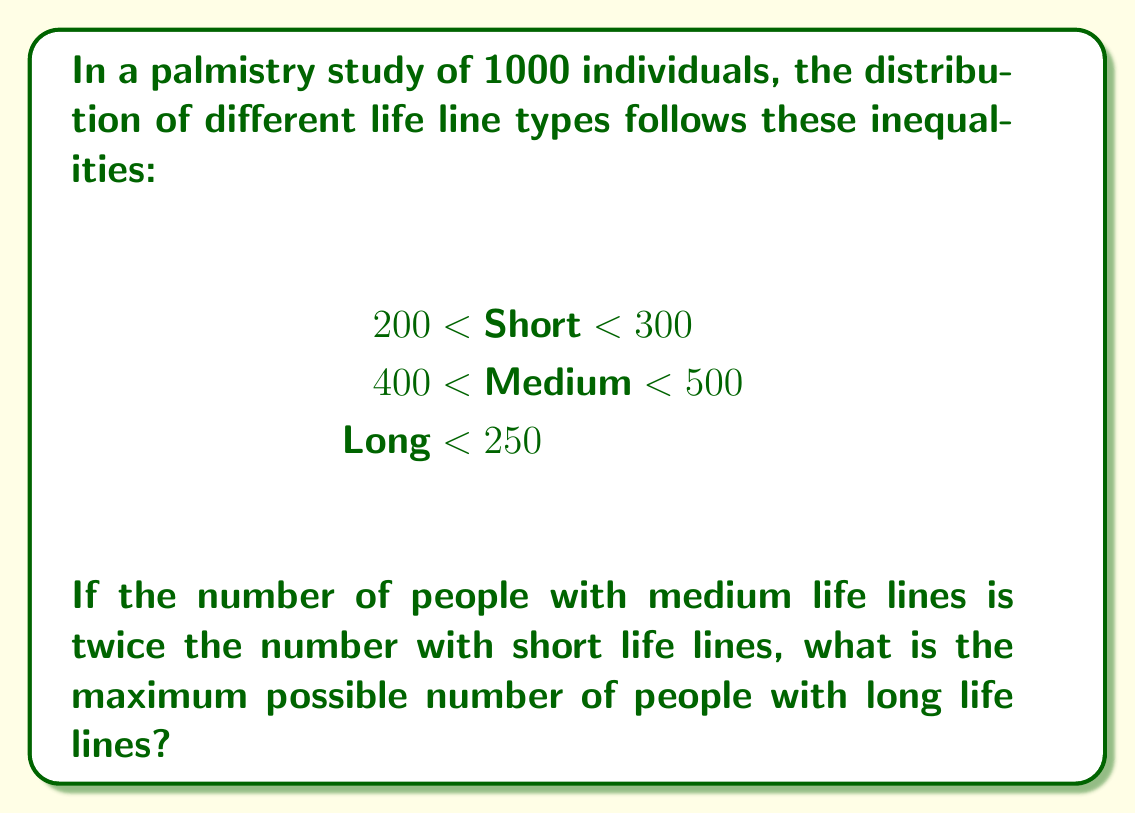Solve this math problem. 1) Let's define variables:
   $s$ = number of people with short life lines
   $m$ = number of people with medium life lines
   $l$ = number of people with long life lines

2) From the given inequalities:
   $200 < s < 300$
   $400 < m < 500$
   $l < 250$

3) We're told that $m = 2s$

4) The total number of people is 1000, so:
   $s + m + l = 1000$

5) Substituting $m = 2s$:
   $s + 2s + l = 1000$
   $3s + l = 1000$

6) To maximize $l$, we need to minimize $s$ while keeping $m$ within its range.
   The minimum value for $s$ is just above 200, let's say 201.

7) If $s = 201$, then $m = 2s = 402$, which satisfies $400 < m < 500$

8) Now we can find the maximum value for $l$:
   $3(201) + l = 1000$
   $603 + l = 1000$
   $l = 1000 - 603 = 397$

9) However, we need to check if this satisfies $l < 250$
   It doesn't, so we need to adjust our calculation.

10) The maximum value for $l$ must be just under 250, let's say 249.

11) Checking if this works with our equation:
    $3s + 249 = 1000$
    $3s = 751$
    $s = 250.33$

12) This value of $s$ satisfies $200 < s < 300$, and $m = 2s = 500.67$, which satisfies $400 < m < 500$

Therefore, the maximum possible number of people with long life lines is 249.
Answer: 249 